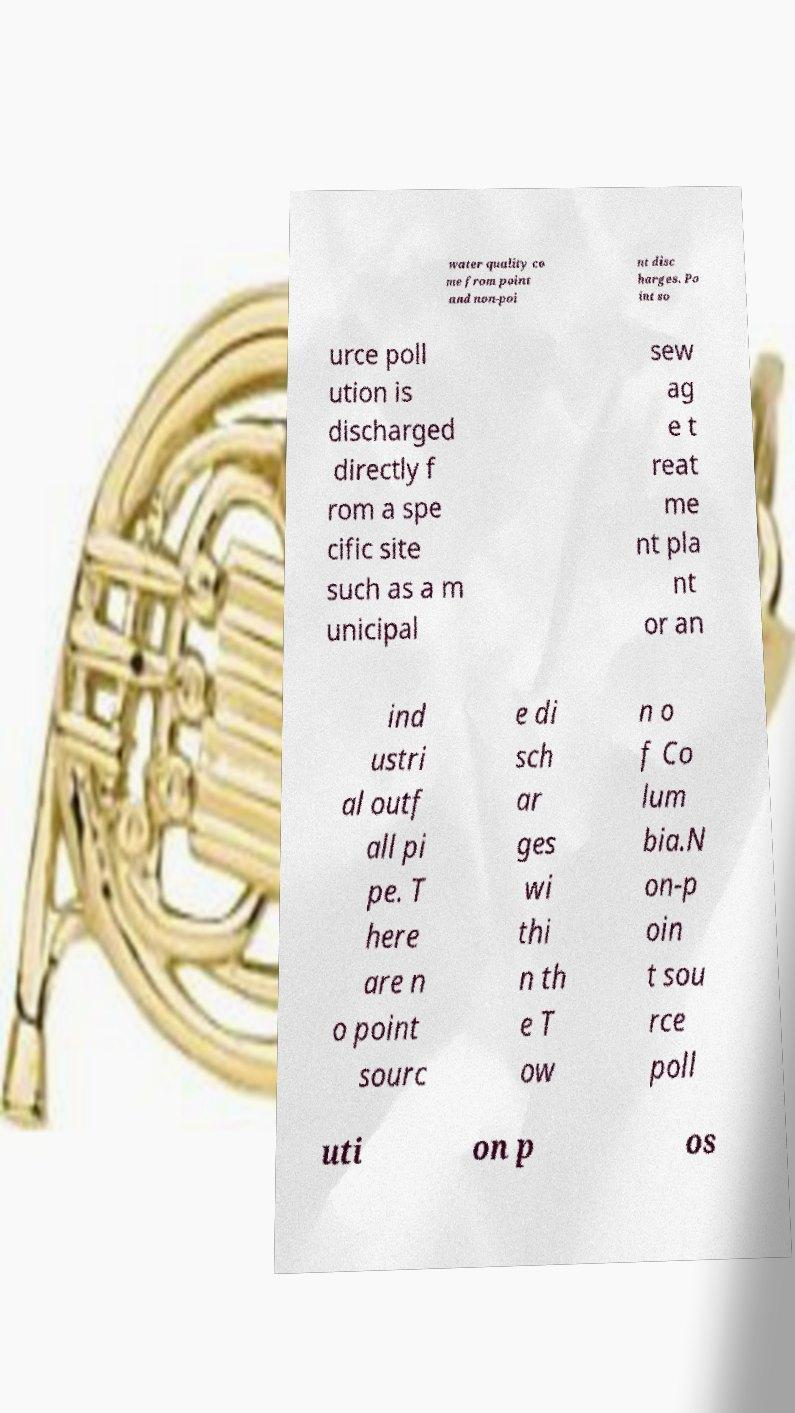What messages or text are displayed in this image? I need them in a readable, typed format. water quality co me from point and non-poi nt disc harges. Po int so urce poll ution is discharged directly f rom a spe cific site such as a m unicipal sew ag e t reat me nt pla nt or an ind ustri al outf all pi pe. T here are n o point sourc e di sch ar ges wi thi n th e T ow n o f Co lum bia.N on-p oin t sou rce poll uti on p os 